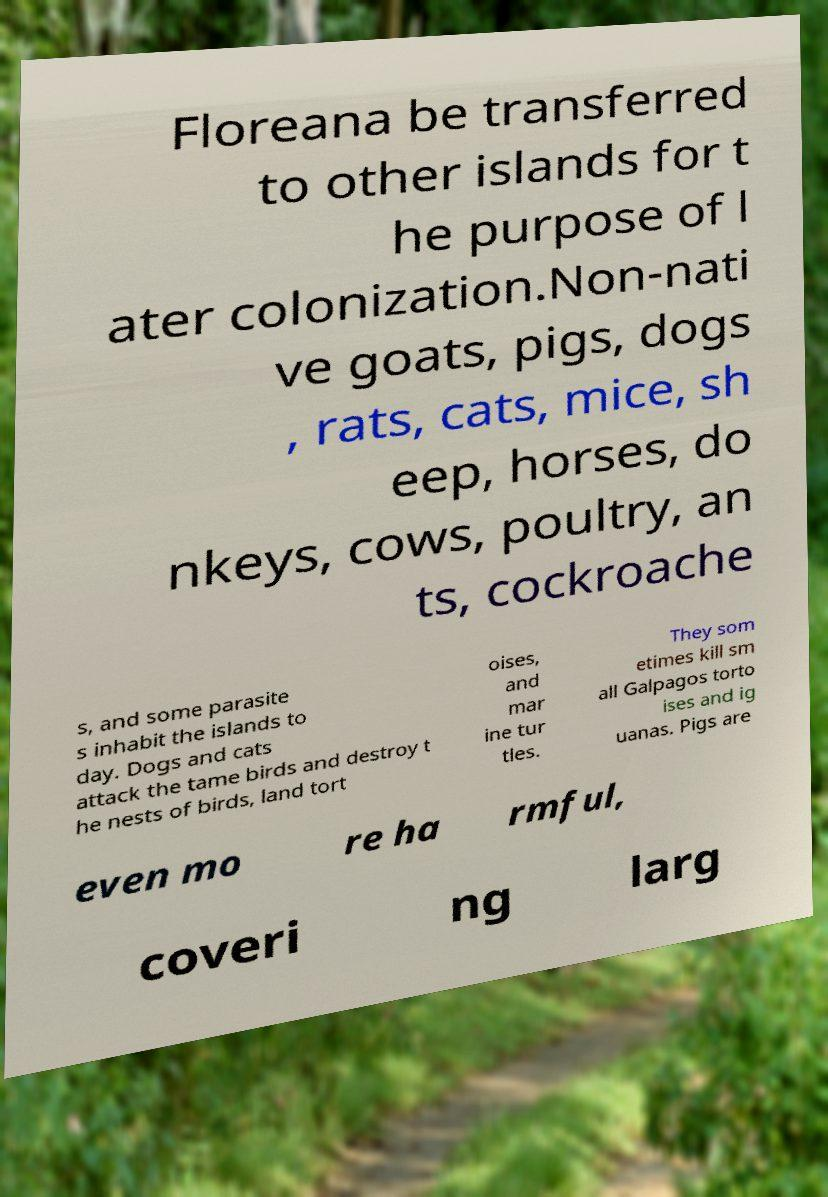What messages or text are displayed in this image? I need them in a readable, typed format. Floreana be transferred to other islands for t he purpose of l ater colonization.Non-nati ve goats, pigs, dogs , rats, cats, mice, sh eep, horses, do nkeys, cows, poultry, an ts, cockroache s, and some parasite s inhabit the islands to day. Dogs and cats attack the tame birds and destroy t he nests of birds, land tort oises, and mar ine tur tles. They som etimes kill sm all Galpagos torto ises and ig uanas. Pigs are even mo re ha rmful, coveri ng larg 